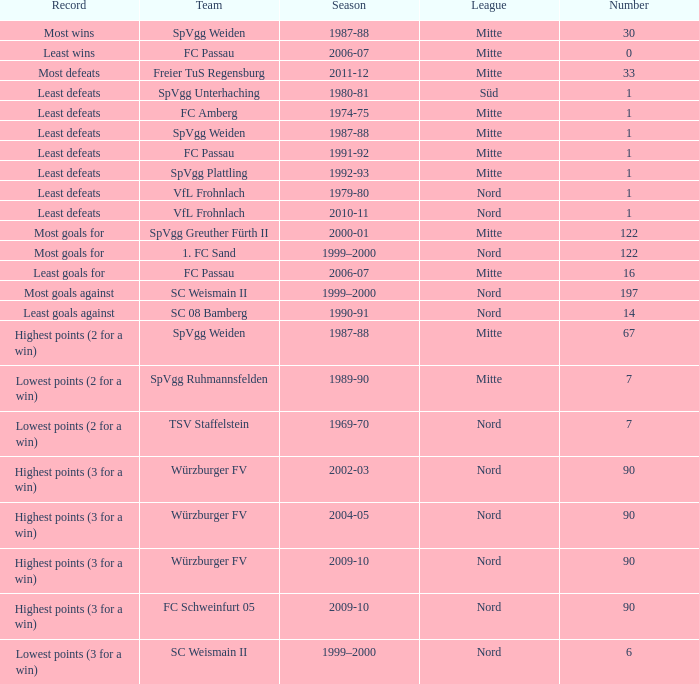What league has a number less than 1? Mitte. 